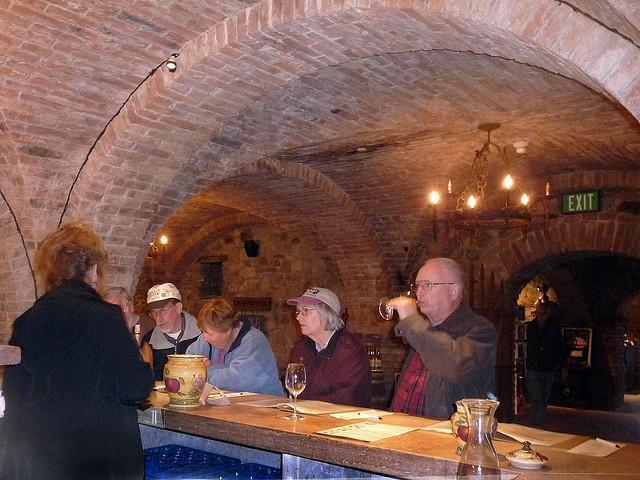How many customers are sitting at the bar?
Give a very brief answer. 4. How many people are in the picture?
Give a very brief answer. 6. 